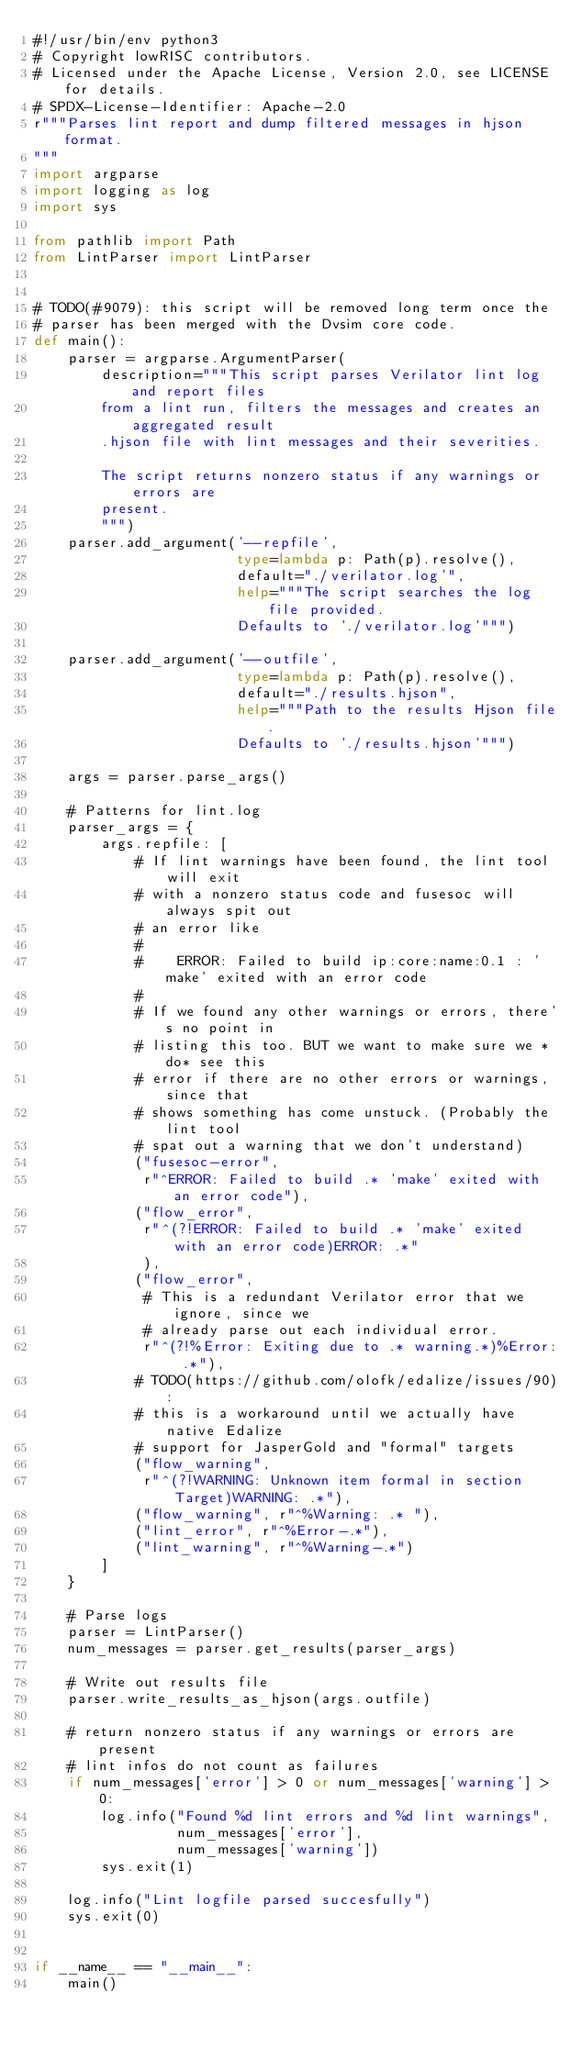<code> <loc_0><loc_0><loc_500><loc_500><_Python_>#!/usr/bin/env python3
# Copyright lowRISC contributors.
# Licensed under the Apache License, Version 2.0, see LICENSE for details.
# SPDX-License-Identifier: Apache-2.0
r"""Parses lint report and dump filtered messages in hjson format.
"""
import argparse
import logging as log
import sys

from pathlib import Path
from LintParser import LintParser


# TODO(#9079): this script will be removed long term once the
# parser has been merged with the Dvsim core code.
def main():
    parser = argparse.ArgumentParser(
        description="""This script parses Verilator lint log and report files
        from a lint run, filters the messages and creates an aggregated result
        .hjson file with lint messages and their severities.

        The script returns nonzero status if any warnings or errors are
        present.
        """)
    parser.add_argument('--repfile',
                        type=lambda p: Path(p).resolve(),
                        default="./verilator.log'",
                        help="""The script searches the log file provided.
                        Defaults to './verilator.log'""")

    parser.add_argument('--outfile',
                        type=lambda p: Path(p).resolve(),
                        default="./results.hjson",
                        help="""Path to the results Hjson file.
                        Defaults to './results.hjson'""")

    args = parser.parse_args()

    # Patterns for lint.log
    parser_args = {
        args.repfile: [
            # If lint warnings have been found, the lint tool will exit
            # with a nonzero status code and fusesoc will always spit out
            # an error like
            #
            #    ERROR: Failed to build ip:core:name:0.1 : 'make' exited with an error code
            #
            # If we found any other warnings or errors, there's no point in
            # listing this too. BUT we want to make sure we *do* see this
            # error if there are no other errors or warnings, since that
            # shows something has come unstuck. (Probably the lint tool
            # spat out a warning that we don't understand)
            ("fusesoc-error",
             r"^ERROR: Failed to build .* 'make' exited with an error code"),
            ("flow_error",
             r"^(?!ERROR: Failed to build .* 'make' exited with an error code)ERROR: .*"
             ),
            ("flow_error",
             # This is a redundant Verilator error that we ignore, since we
             # already parse out each individual error.
             r"^(?!%Error: Exiting due to .* warning.*)%Error: .*"),
            # TODO(https://github.com/olofk/edalize/issues/90):
            # this is a workaround until we actually have native Edalize
            # support for JasperGold and "formal" targets
            ("flow_warning",
             r"^(?!WARNING: Unknown item formal in section Target)WARNING: .*"),
            ("flow_warning", r"^%Warning: .* "),
            ("lint_error", r"^%Error-.*"),
            ("lint_warning", r"^%Warning-.*")
        ]
    }

    # Parse logs
    parser = LintParser()
    num_messages = parser.get_results(parser_args)

    # Write out results file
    parser.write_results_as_hjson(args.outfile)

    # return nonzero status if any warnings or errors are present
    # lint infos do not count as failures
    if num_messages['error'] > 0 or num_messages['warning'] > 0:
        log.info("Found %d lint errors and %d lint warnings",
                 num_messages['error'],
                 num_messages['warning'])
        sys.exit(1)

    log.info("Lint logfile parsed succesfully")
    sys.exit(0)


if __name__ == "__main__":
    main()
</code> 